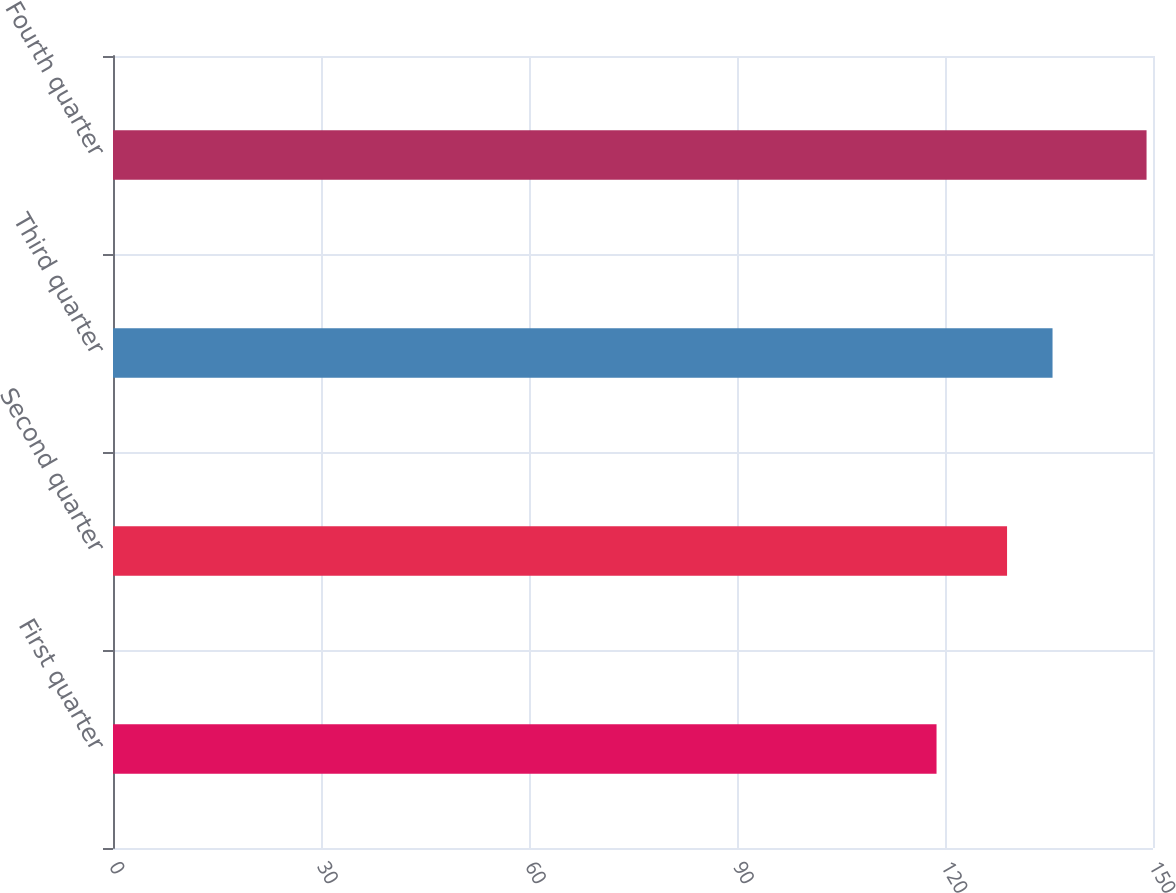<chart> <loc_0><loc_0><loc_500><loc_500><bar_chart><fcel>First quarter<fcel>Second quarter<fcel>Third quarter<fcel>Fourth quarter<nl><fcel>118.78<fcel>128.95<fcel>135.51<fcel>149.07<nl></chart> 